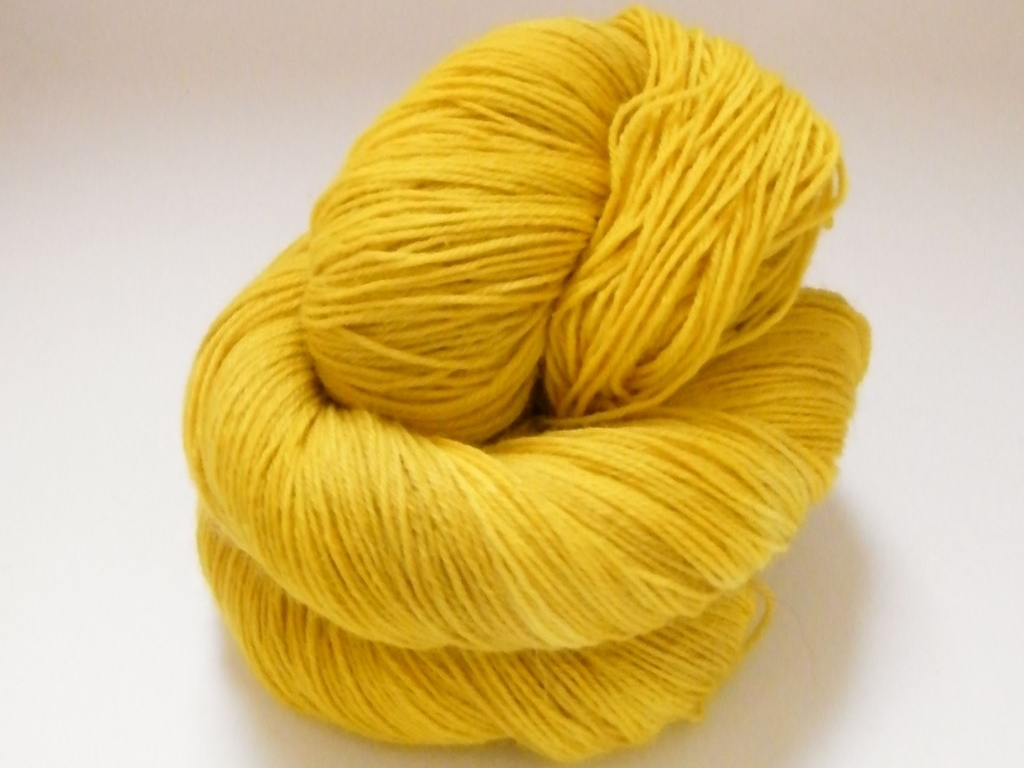How does the quality of this yarn compare to what is needed for professional crafting? The yarn in the image looks to be of high quality, which is suitable for both professional and hobbyist crafting. The fibers appear smooth and tightly spun, indicating good strength and consistency essential for intricate and durable creations. Professional crafters would also appreciate the even dye and the lack of pilling or fraying. If someone were interested in starting to knit, would this be a good type of yarn to begin with? Yes, this yarn would be an excellent choice for someone new to knitting. The thickness and smoothness of the yarn will make it easier to work with, as it will glide seamlessly on the needles and help prevent beginners from dropping stitches. Additionally, the solid color allows for easy visibility of stitch patterns, which can aid in the learning process. 